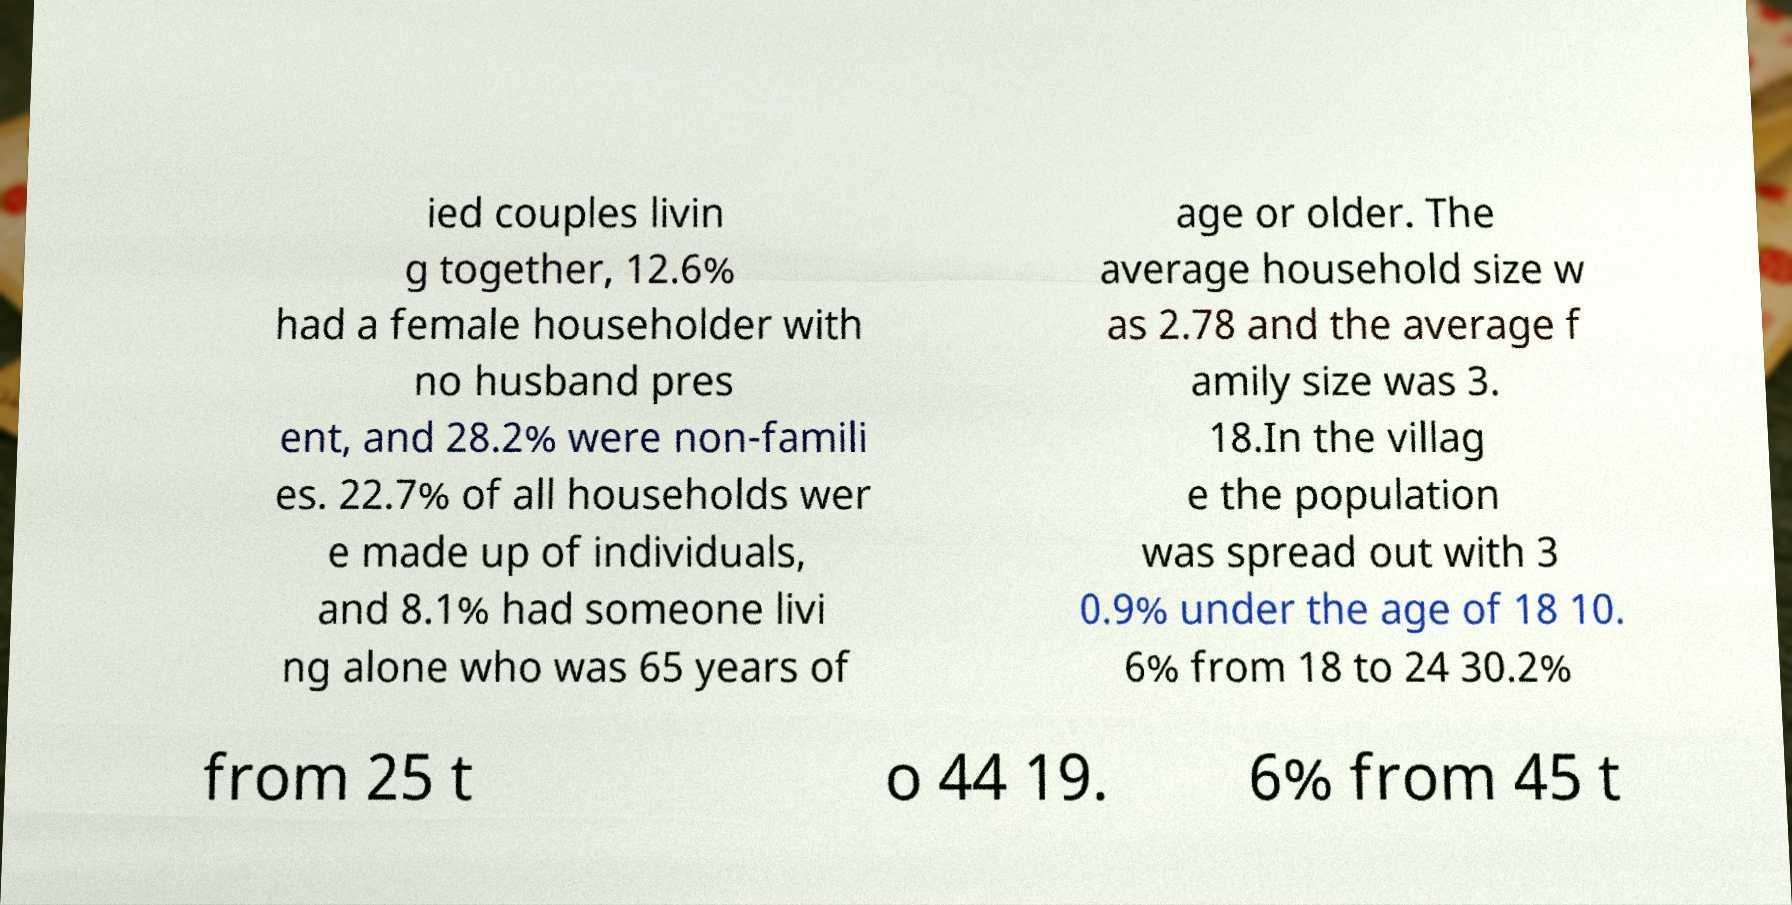Please identify and transcribe the text found in this image. ied couples livin g together, 12.6% had a female householder with no husband pres ent, and 28.2% were non-famili es. 22.7% of all households wer e made up of individuals, and 8.1% had someone livi ng alone who was 65 years of age or older. The average household size w as 2.78 and the average f amily size was 3. 18.In the villag e the population was spread out with 3 0.9% under the age of 18 10. 6% from 18 to 24 30.2% from 25 t o 44 19. 6% from 45 t 